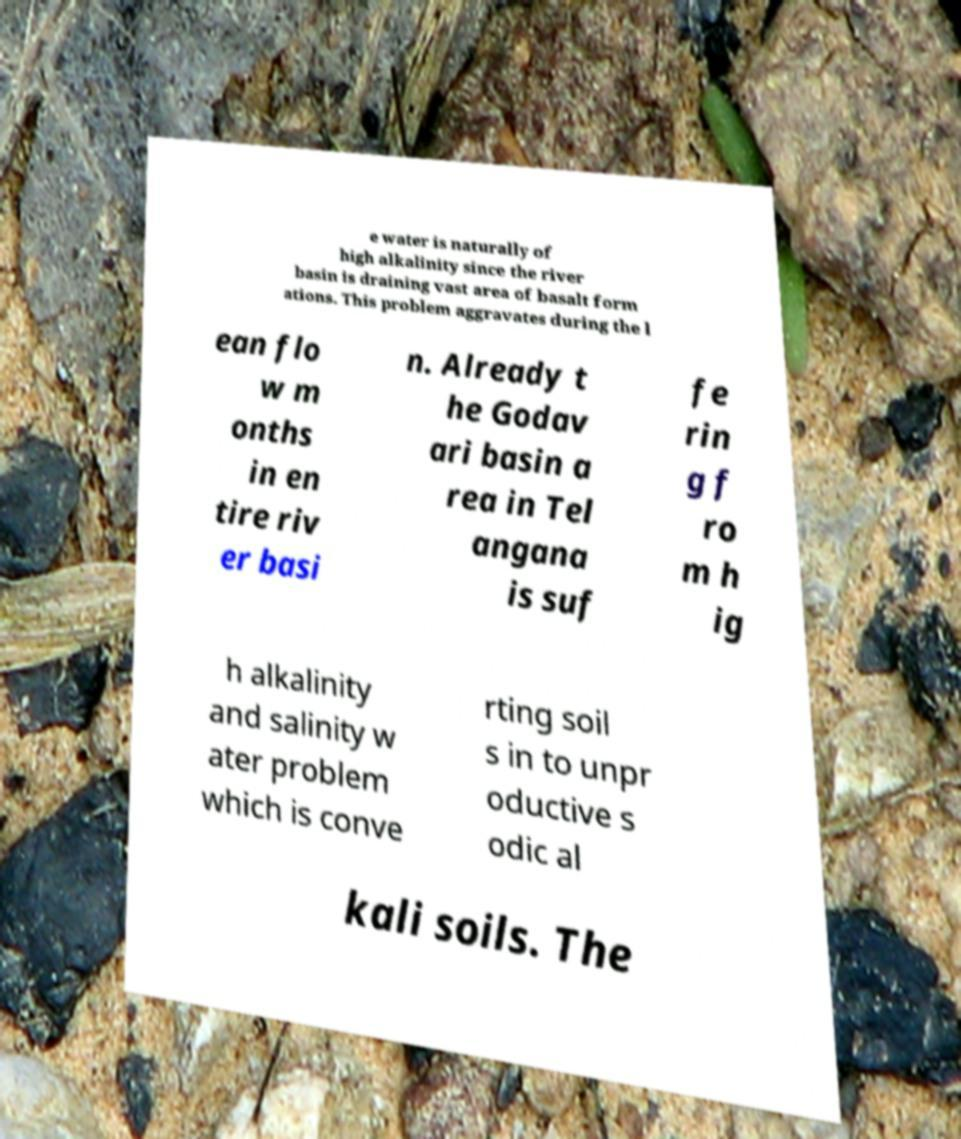I need the written content from this picture converted into text. Can you do that? e water is naturally of high alkalinity since the river basin is draining vast area of basalt form ations. This problem aggravates during the l ean flo w m onths in en tire riv er basi n. Already t he Godav ari basin a rea in Tel angana is suf fe rin g f ro m h ig h alkalinity and salinity w ater problem which is conve rting soil s in to unpr oductive s odic al kali soils. The 